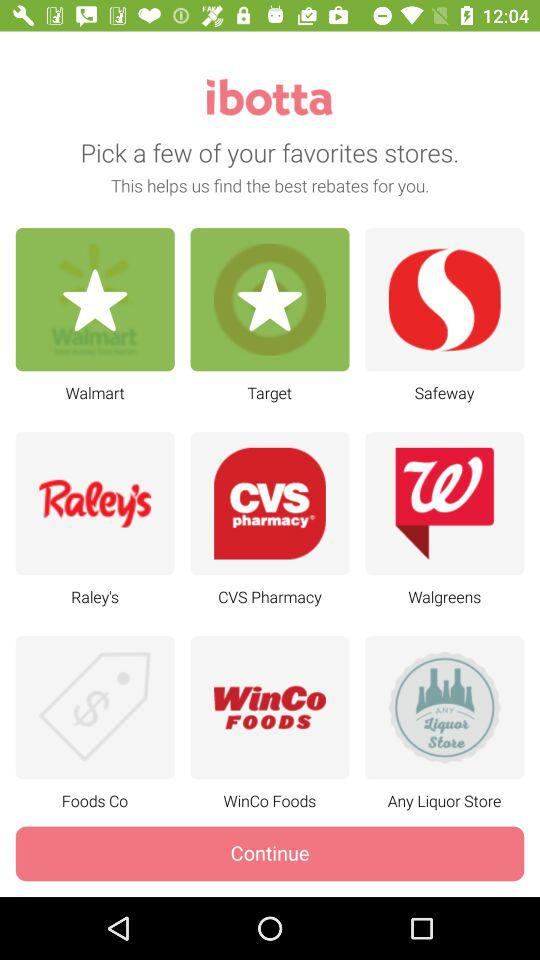What are the chosen favorite stores? The chosen favorite stores are "Walmart" and "Target". 